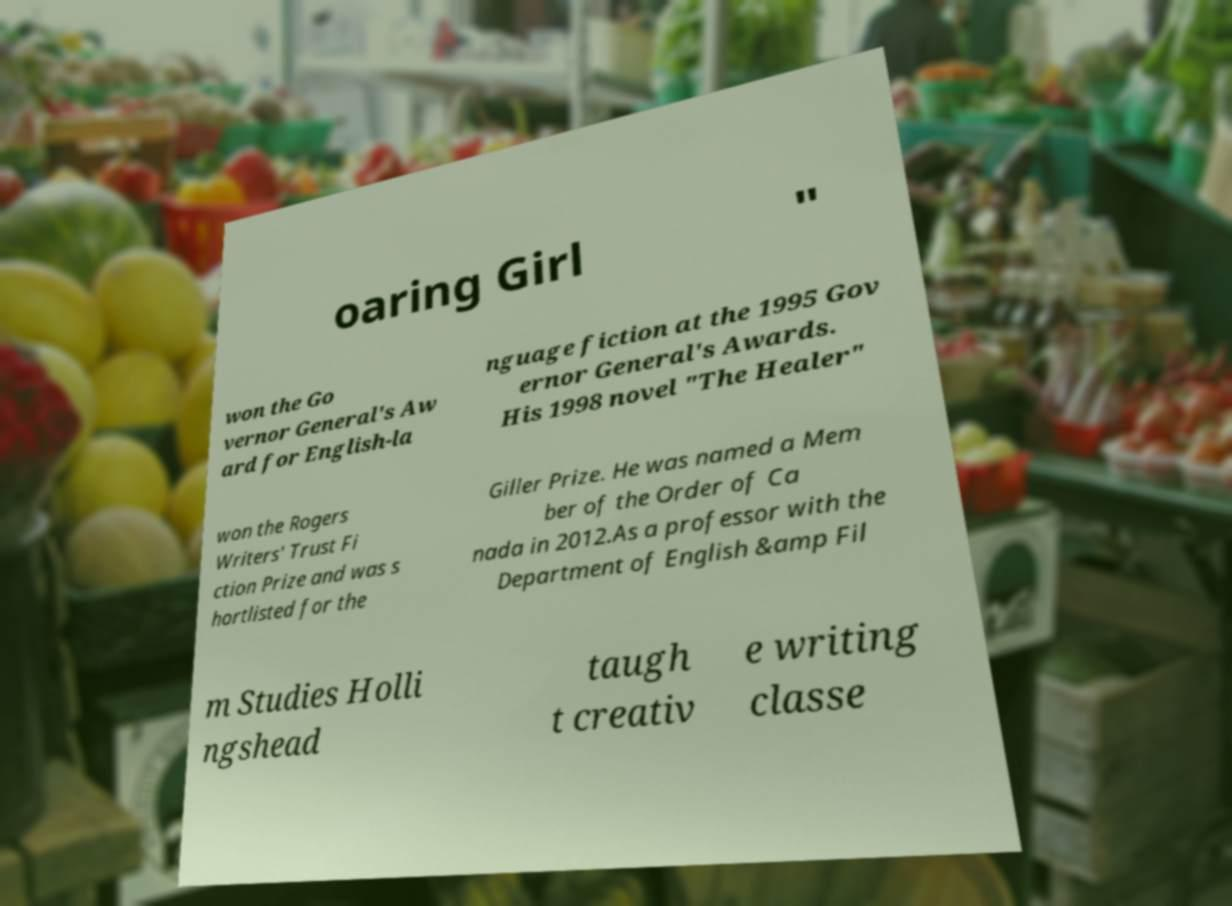There's text embedded in this image that I need extracted. Can you transcribe it verbatim? oaring Girl " won the Go vernor General's Aw ard for English-la nguage fiction at the 1995 Gov ernor General's Awards. His 1998 novel "The Healer" won the Rogers Writers' Trust Fi ction Prize and was s hortlisted for the Giller Prize. He was named a Mem ber of the Order of Ca nada in 2012.As a professor with the Department of English &amp Fil m Studies Holli ngshead taugh t creativ e writing classe 